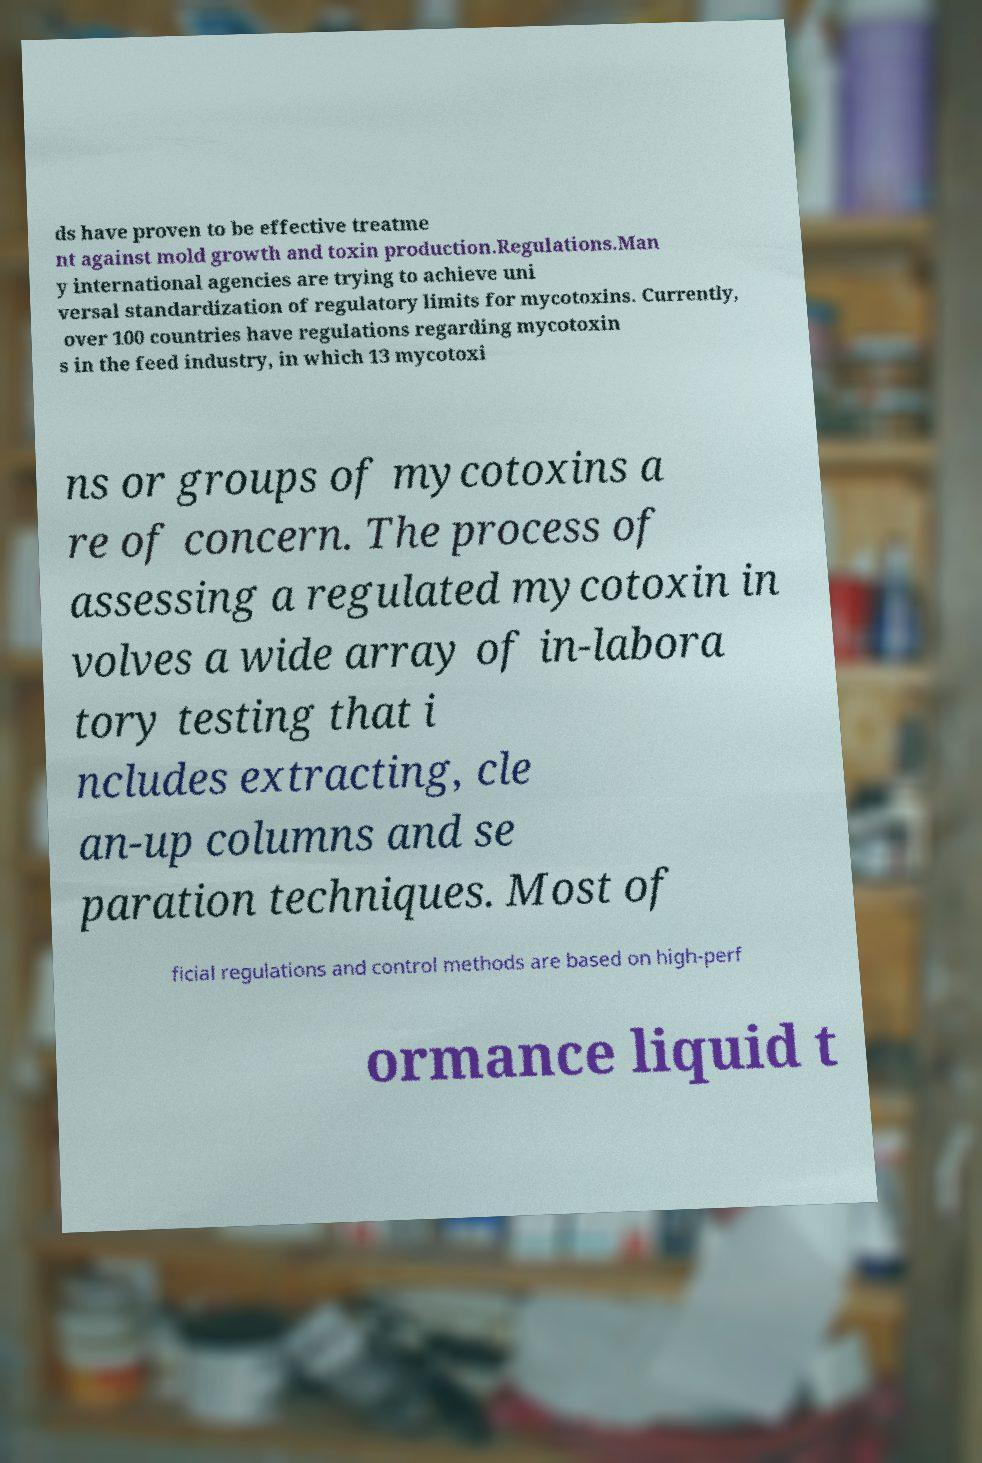What messages or text are displayed in this image? I need them in a readable, typed format. ds have proven to be effective treatme nt against mold growth and toxin production.Regulations.Man y international agencies are trying to achieve uni versal standardization of regulatory limits for mycotoxins. Currently, over 100 countries have regulations regarding mycotoxin s in the feed industry, in which 13 mycotoxi ns or groups of mycotoxins a re of concern. The process of assessing a regulated mycotoxin in volves a wide array of in-labora tory testing that i ncludes extracting, cle an-up columns and se paration techniques. Most of ficial regulations and control methods are based on high-perf ormance liquid t 